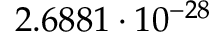<formula> <loc_0><loc_0><loc_500><loc_500>2 . 6 8 8 1 \cdot 1 0 ^ { - 2 8 }</formula> 